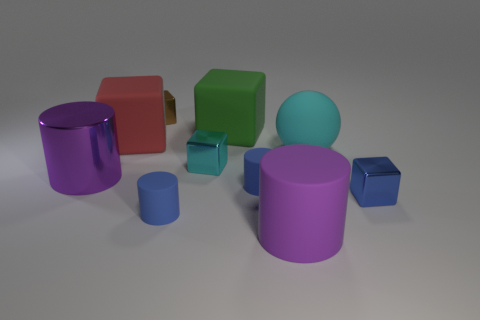Subtract all purple cylinders. How many cylinders are left? 2 Subtract all cyan shiny blocks. How many blocks are left? 4 Subtract 1 blue cubes. How many objects are left? 9 Subtract all cylinders. How many objects are left? 6 Subtract 4 cylinders. How many cylinders are left? 0 Subtract all yellow balls. Subtract all gray cylinders. How many balls are left? 1 Subtract all brown cylinders. How many red blocks are left? 1 Subtract all small cylinders. Subtract all large purple matte cylinders. How many objects are left? 7 Add 5 blue metallic cubes. How many blue metallic cubes are left? 6 Add 7 purple shiny things. How many purple shiny things exist? 8 